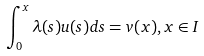Convert formula to latex. <formula><loc_0><loc_0><loc_500><loc_500>\int _ { 0 } ^ { x } \lambda ( s ) u ( s ) d s = v ( x ) , x \in I</formula> 